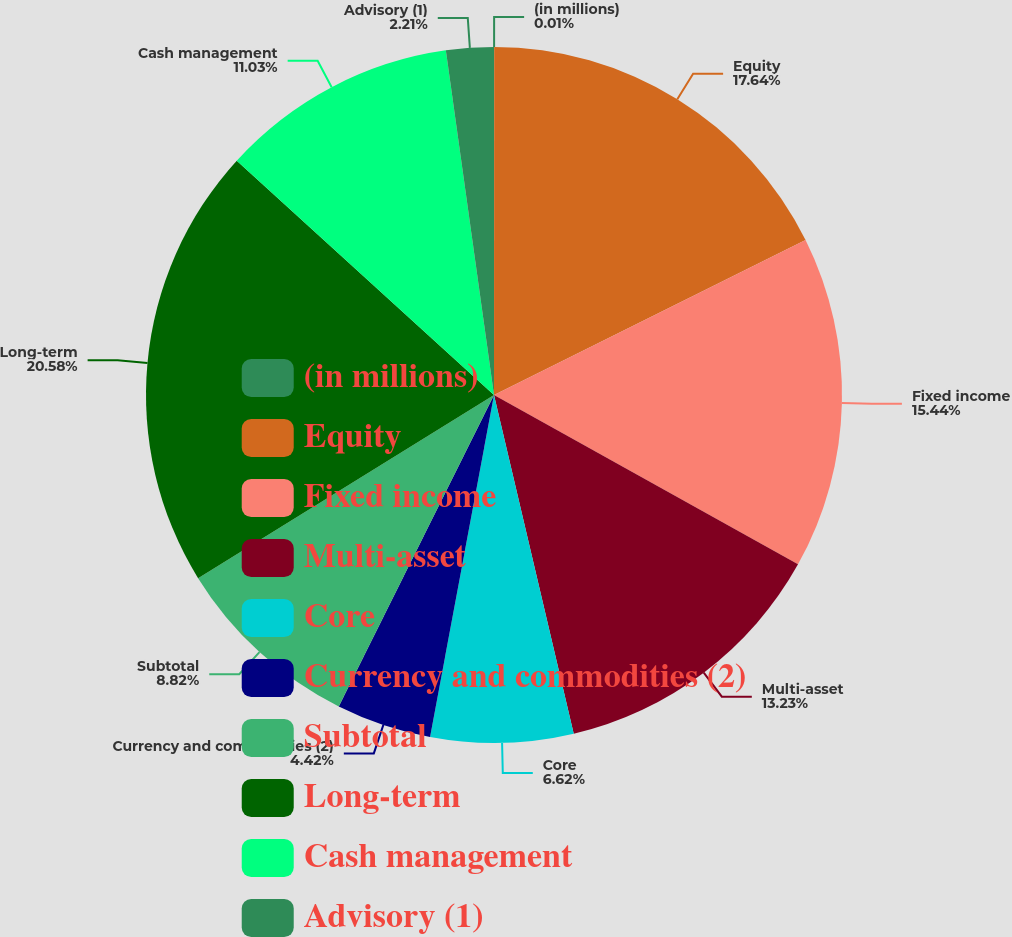Convert chart to OTSL. <chart><loc_0><loc_0><loc_500><loc_500><pie_chart><fcel>(in millions)<fcel>Equity<fcel>Fixed income<fcel>Multi-asset<fcel>Core<fcel>Currency and commodities (2)<fcel>Subtotal<fcel>Long-term<fcel>Cash management<fcel>Advisory (1)<nl><fcel>0.01%<fcel>17.64%<fcel>15.44%<fcel>13.23%<fcel>6.62%<fcel>4.42%<fcel>8.82%<fcel>20.58%<fcel>11.03%<fcel>2.21%<nl></chart> 